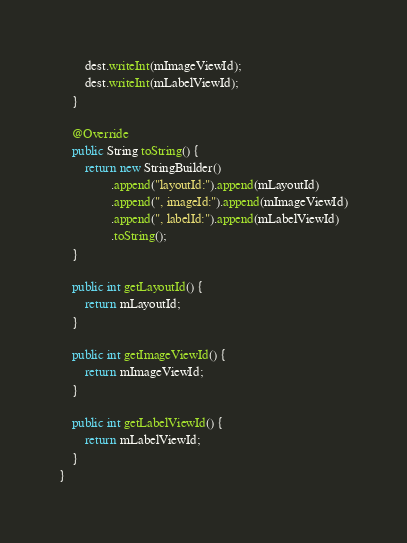<code> <loc_0><loc_0><loc_500><loc_500><_Java_>        dest.writeInt(mImageViewId);
        dest.writeInt(mLabelViewId);
    }

    @Override
    public String toString() {
        return new StringBuilder()
                .append("layoutId:").append(mLayoutId)
                .append(", imageId:").append(mImageViewId)
                .append(", labelId:").append(mLabelViewId)
                .toString();
    }

    public int getLayoutId() {
        return mLayoutId;
    }

    public int getImageViewId() {
        return mImageViewId;
    }

    public int getLabelViewId() {
        return mLabelViewId;
    }
}
</code> 